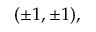Convert formula to latex. <formula><loc_0><loc_0><loc_500><loc_500>( \pm 1 , \pm 1 ) ,</formula> 